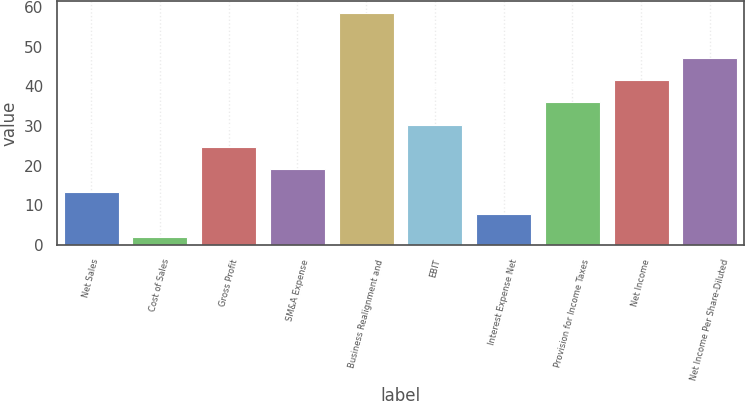Convert chart. <chart><loc_0><loc_0><loc_500><loc_500><bar_chart><fcel>Net Sales<fcel>Cost of Sales<fcel>Gross Profit<fcel>SM&A Expense<fcel>Business Realignment and<fcel>EBIT<fcel>Interest Expense Net<fcel>Provision for Income Taxes<fcel>Net Income<fcel>Net Income Per Share-Diluted<nl><fcel>13.38<fcel>2.1<fcel>24.66<fcel>19.02<fcel>58.5<fcel>30.3<fcel>7.74<fcel>35.94<fcel>41.58<fcel>47.22<nl></chart> 